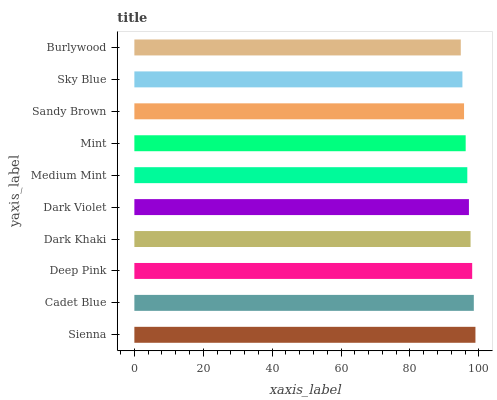Is Burlywood the minimum?
Answer yes or no. Yes. Is Sienna the maximum?
Answer yes or no. Yes. Is Cadet Blue the minimum?
Answer yes or no. No. Is Cadet Blue the maximum?
Answer yes or no. No. Is Sienna greater than Cadet Blue?
Answer yes or no. Yes. Is Cadet Blue less than Sienna?
Answer yes or no. Yes. Is Cadet Blue greater than Sienna?
Answer yes or no. No. Is Sienna less than Cadet Blue?
Answer yes or no. No. Is Dark Violet the high median?
Answer yes or no. Yes. Is Medium Mint the low median?
Answer yes or no. Yes. Is Cadet Blue the high median?
Answer yes or no. No. Is Dark Khaki the low median?
Answer yes or no. No. 